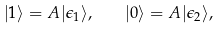Convert formula to latex. <formula><loc_0><loc_0><loc_500><loc_500>| 1 \rangle = A | \epsilon _ { 1 } \rangle , \quad | 0 \rangle = A | \epsilon _ { 2 } \rangle ,</formula> 